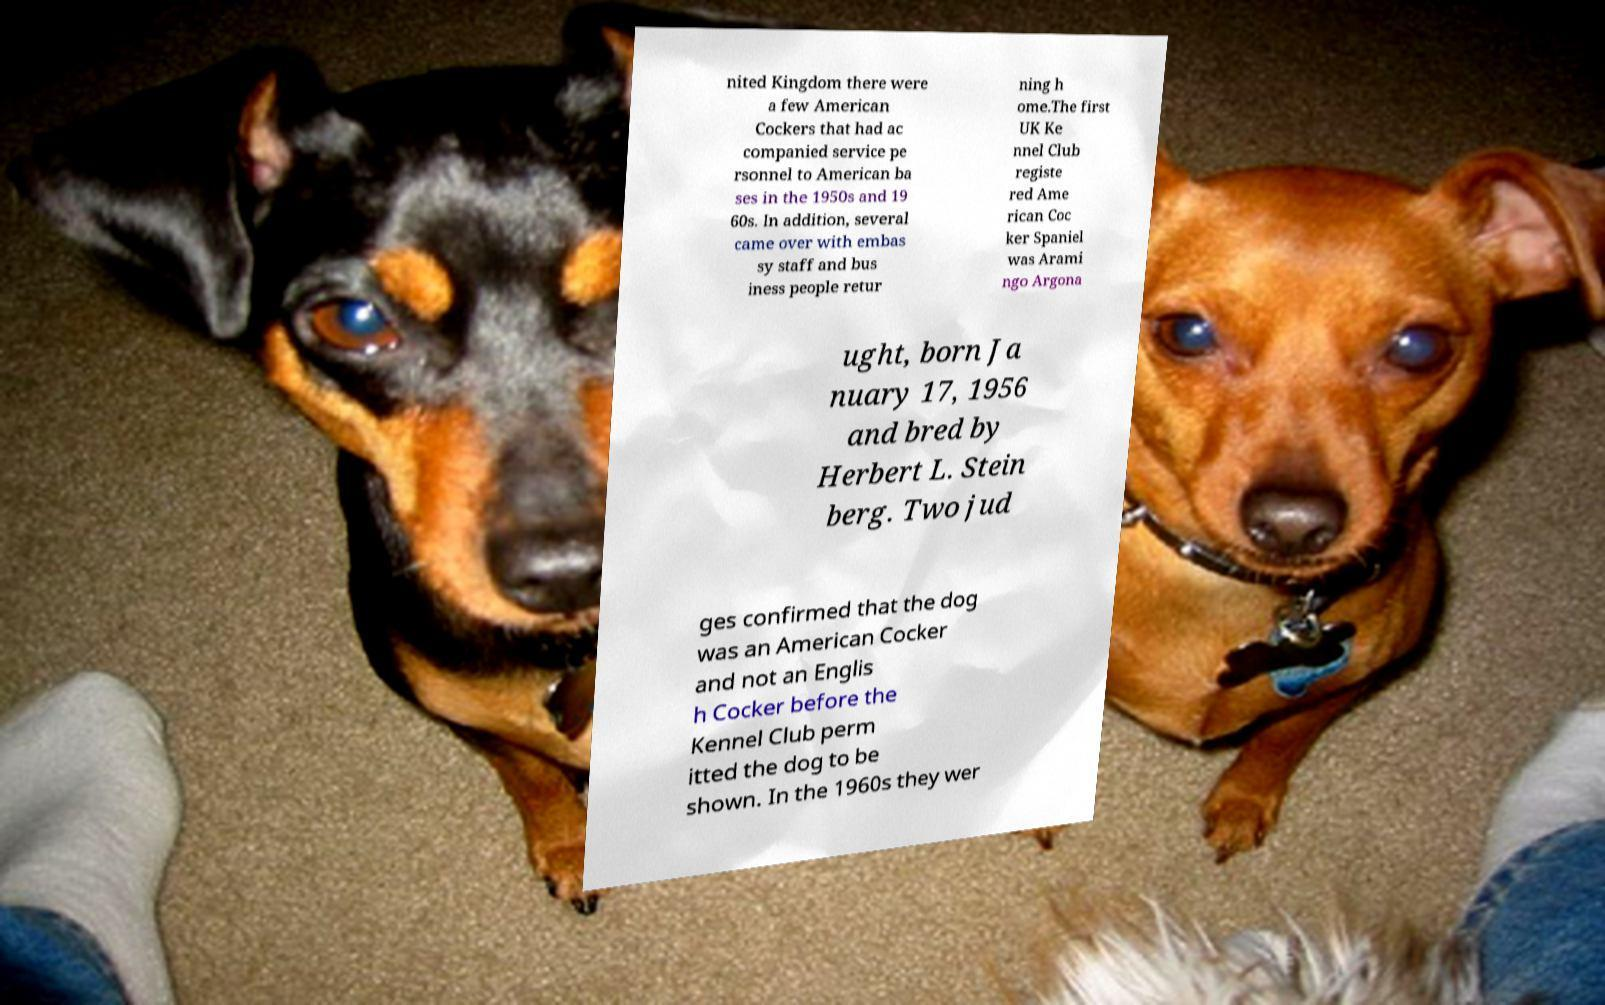Could you assist in decoding the text presented in this image and type it out clearly? nited Kingdom there were a few American Cockers that had ac companied service pe rsonnel to American ba ses in the 1950s and 19 60s. In addition, several came over with embas sy staff and bus iness people retur ning h ome.The first UK Ke nnel Club registe red Ame rican Coc ker Spaniel was Arami ngo Argona ught, born Ja nuary 17, 1956 and bred by Herbert L. Stein berg. Two jud ges confirmed that the dog was an American Cocker and not an Englis h Cocker before the Kennel Club perm itted the dog to be shown. In the 1960s they wer 